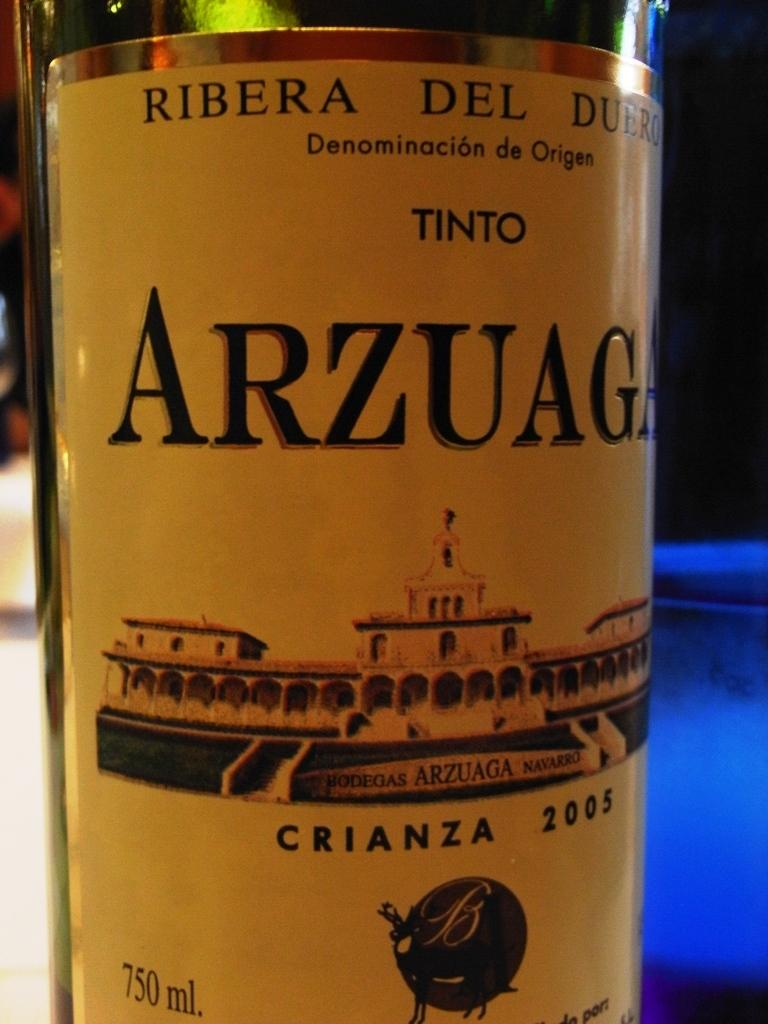<image>
Summarize the visual content of the image. A bottle of Arzuaga Crianza 2005 wine label 